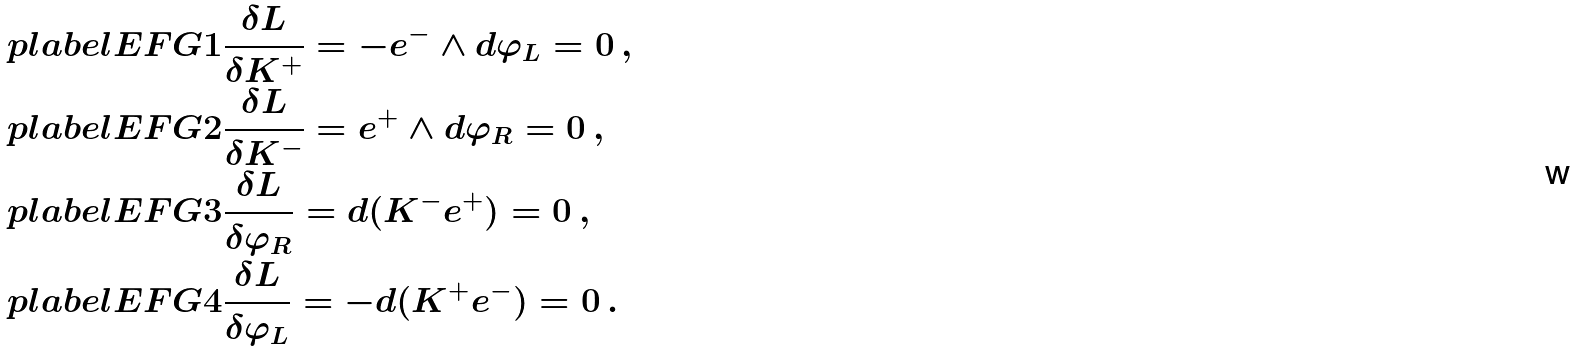Convert formula to latex. <formula><loc_0><loc_0><loc_500><loc_500>\ p l a b e l { E F G 1 } & \frac { \delta L } { \delta K ^ { + } } = - e ^ { - } \wedge d \varphi _ { L } = 0 \, , \\ \ p l a b e l { E F G 2 } & \frac { \delta L } { \delta K ^ { - } } = e ^ { + } \wedge d \varphi _ { R } = 0 \, , \\ \ p l a b e l { E F G 3 } & \frac { \delta L } { \delta \varphi _ { R } } = d ( K ^ { - } e ^ { + } ) = 0 \, , \\ \ p l a b e l { E F G 4 } & \frac { \delta L } { \delta \varphi _ { L } } = - d ( K ^ { + } e ^ { - } ) = 0 \, .</formula> 